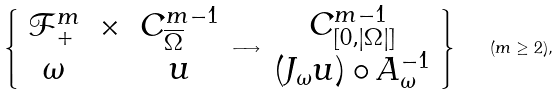Convert formula to latex. <formula><loc_0><loc_0><loc_500><loc_500>\left \{ \begin{array} { c c c } \mathcal { F } _ { + } ^ { m } & \times & C ^ { m - 1 } _ { \overline { \Omega } } \\ \omega & & u \end{array} \longrightarrow \begin{array} { c } C ^ { m - 1 } _ { [ 0 , | \Omega | ] } \\ ( J _ { \omega } u ) \circ A _ { \omega } ^ { - 1 } \end{array} \right \} \quad ( m \geq 2 ) ,</formula> 